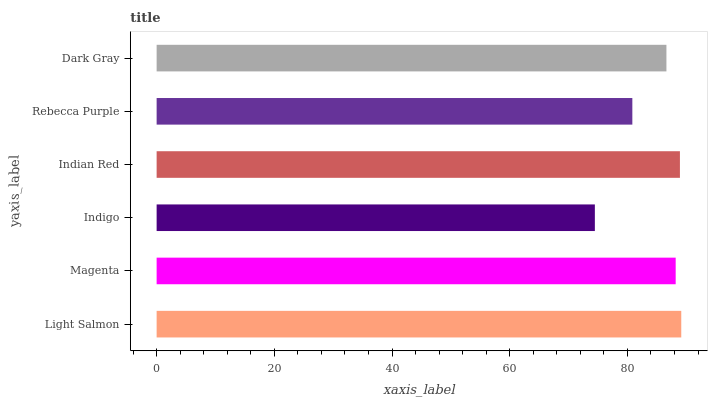Is Indigo the minimum?
Answer yes or no. Yes. Is Light Salmon the maximum?
Answer yes or no. Yes. Is Magenta the minimum?
Answer yes or no. No. Is Magenta the maximum?
Answer yes or no. No. Is Light Salmon greater than Magenta?
Answer yes or no. Yes. Is Magenta less than Light Salmon?
Answer yes or no. Yes. Is Magenta greater than Light Salmon?
Answer yes or no. No. Is Light Salmon less than Magenta?
Answer yes or no. No. Is Magenta the high median?
Answer yes or no. Yes. Is Dark Gray the low median?
Answer yes or no. Yes. Is Indian Red the high median?
Answer yes or no. No. Is Rebecca Purple the low median?
Answer yes or no. No. 